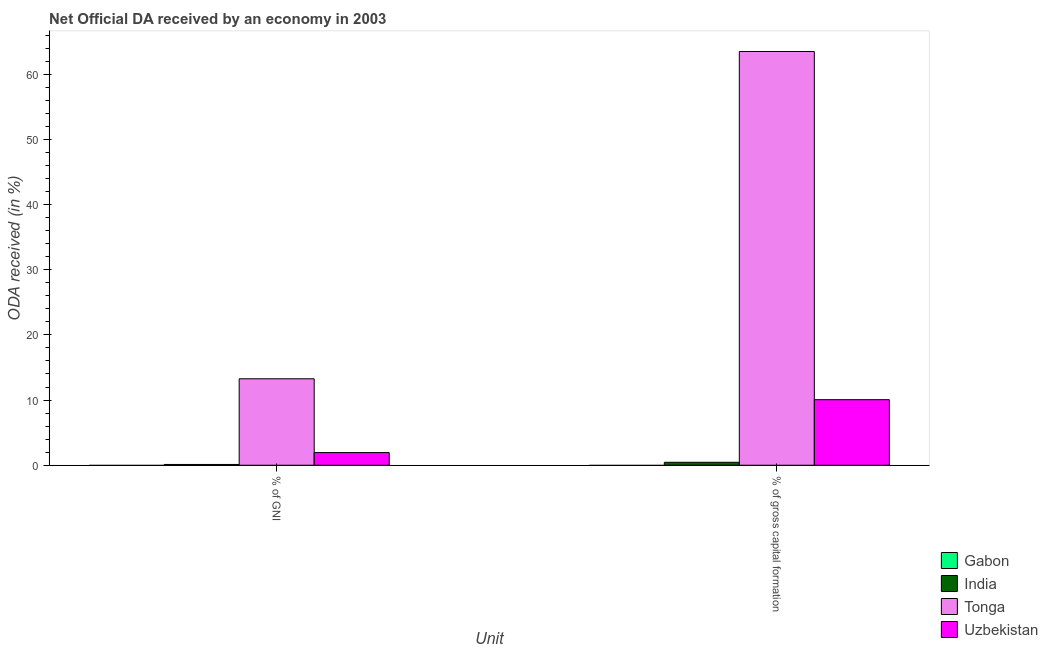How many groups of bars are there?
Offer a terse response. 2. Are the number of bars per tick equal to the number of legend labels?
Provide a short and direct response. No. Are the number of bars on each tick of the X-axis equal?
Keep it short and to the point. Yes. How many bars are there on the 1st tick from the left?
Keep it short and to the point. 3. How many bars are there on the 2nd tick from the right?
Provide a succinct answer. 3. What is the label of the 1st group of bars from the left?
Keep it short and to the point. % of GNI. Across all countries, what is the maximum oda received as percentage of gross capital formation?
Your answer should be compact. 63.47. In which country was the oda received as percentage of gross capital formation maximum?
Provide a succinct answer. Tonga. What is the total oda received as percentage of gross capital formation in the graph?
Provide a short and direct response. 73.98. What is the difference between the oda received as percentage of gni in India and that in Uzbekistan?
Keep it short and to the point. -1.82. What is the difference between the oda received as percentage of gross capital formation in India and the oda received as percentage of gni in Gabon?
Make the answer very short. 0.45. What is the average oda received as percentage of gni per country?
Make the answer very short. 3.83. What is the difference between the oda received as percentage of gross capital formation and oda received as percentage of gni in Tonga?
Give a very brief answer. 50.21. What is the ratio of the oda received as percentage of gross capital formation in Uzbekistan to that in Tonga?
Offer a terse response. 0.16. Is the oda received as percentage of gni in Uzbekistan less than that in Tonga?
Your response must be concise. Yes. Are all the bars in the graph horizontal?
Offer a very short reply. No. Does the graph contain any zero values?
Your answer should be very brief. Yes. What is the title of the graph?
Your response must be concise. Net Official DA received by an economy in 2003. What is the label or title of the X-axis?
Your answer should be compact. Unit. What is the label or title of the Y-axis?
Give a very brief answer. ODA received (in %). What is the ODA received (in %) of Gabon in % of GNI?
Your answer should be very brief. 0. What is the ODA received (in %) of India in % of GNI?
Provide a succinct answer. 0.12. What is the ODA received (in %) of Tonga in % of GNI?
Your response must be concise. 13.26. What is the ODA received (in %) in Uzbekistan in % of GNI?
Your response must be concise. 1.94. What is the ODA received (in %) in India in % of gross capital formation?
Your answer should be very brief. 0.45. What is the ODA received (in %) of Tonga in % of gross capital formation?
Make the answer very short. 63.47. What is the ODA received (in %) of Uzbekistan in % of gross capital formation?
Ensure brevity in your answer.  10.06. Across all Unit, what is the maximum ODA received (in %) of India?
Offer a very short reply. 0.45. Across all Unit, what is the maximum ODA received (in %) of Tonga?
Keep it short and to the point. 63.47. Across all Unit, what is the maximum ODA received (in %) in Uzbekistan?
Offer a very short reply. 10.06. Across all Unit, what is the minimum ODA received (in %) of India?
Give a very brief answer. 0.12. Across all Unit, what is the minimum ODA received (in %) of Tonga?
Offer a terse response. 13.26. Across all Unit, what is the minimum ODA received (in %) of Uzbekistan?
Keep it short and to the point. 1.94. What is the total ODA received (in %) of Gabon in the graph?
Ensure brevity in your answer.  0. What is the total ODA received (in %) of India in the graph?
Give a very brief answer. 0.57. What is the total ODA received (in %) of Tonga in the graph?
Provide a succinct answer. 76.73. What is the total ODA received (in %) of Uzbekistan in the graph?
Your response must be concise. 12. What is the difference between the ODA received (in %) of India in % of GNI and that in % of gross capital formation?
Ensure brevity in your answer.  -0.33. What is the difference between the ODA received (in %) in Tonga in % of GNI and that in % of gross capital formation?
Offer a terse response. -50.21. What is the difference between the ODA received (in %) of Uzbekistan in % of GNI and that in % of gross capital formation?
Provide a succinct answer. -8.11. What is the difference between the ODA received (in %) in India in % of GNI and the ODA received (in %) in Tonga in % of gross capital formation?
Ensure brevity in your answer.  -63.35. What is the difference between the ODA received (in %) in India in % of GNI and the ODA received (in %) in Uzbekistan in % of gross capital formation?
Your response must be concise. -9.94. What is the difference between the ODA received (in %) in Tonga in % of GNI and the ODA received (in %) in Uzbekistan in % of gross capital formation?
Offer a very short reply. 3.21. What is the average ODA received (in %) of India per Unit?
Your answer should be compact. 0.29. What is the average ODA received (in %) of Tonga per Unit?
Make the answer very short. 38.37. What is the average ODA received (in %) of Uzbekistan per Unit?
Ensure brevity in your answer.  6. What is the difference between the ODA received (in %) of India and ODA received (in %) of Tonga in % of GNI?
Provide a short and direct response. -13.14. What is the difference between the ODA received (in %) in India and ODA received (in %) in Uzbekistan in % of GNI?
Make the answer very short. -1.82. What is the difference between the ODA received (in %) in Tonga and ODA received (in %) in Uzbekistan in % of GNI?
Give a very brief answer. 11.32. What is the difference between the ODA received (in %) of India and ODA received (in %) of Tonga in % of gross capital formation?
Keep it short and to the point. -63.02. What is the difference between the ODA received (in %) of India and ODA received (in %) of Uzbekistan in % of gross capital formation?
Your answer should be compact. -9.61. What is the difference between the ODA received (in %) of Tonga and ODA received (in %) of Uzbekistan in % of gross capital formation?
Your answer should be very brief. 53.42. What is the ratio of the ODA received (in %) in India in % of GNI to that in % of gross capital formation?
Ensure brevity in your answer.  0.26. What is the ratio of the ODA received (in %) in Tonga in % of GNI to that in % of gross capital formation?
Make the answer very short. 0.21. What is the ratio of the ODA received (in %) of Uzbekistan in % of GNI to that in % of gross capital formation?
Your response must be concise. 0.19. What is the difference between the highest and the second highest ODA received (in %) in India?
Your answer should be very brief. 0.33. What is the difference between the highest and the second highest ODA received (in %) in Tonga?
Ensure brevity in your answer.  50.21. What is the difference between the highest and the second highest ODA received (in %) of Uzbekistan?
Your answer should be very brief. 8.11. What is the difference between the highest and the lowest ODA received (in %) of India?
Offer a terse response. 0.33. What is the difference between the highest and the lowest ODA received (in %) of Tonga?
Your answer should be very brief. 50.21. What is the difference between the highest and the lowest ODA received (in %) in Uzbekistan?
Your response must be concise. 8.11. 